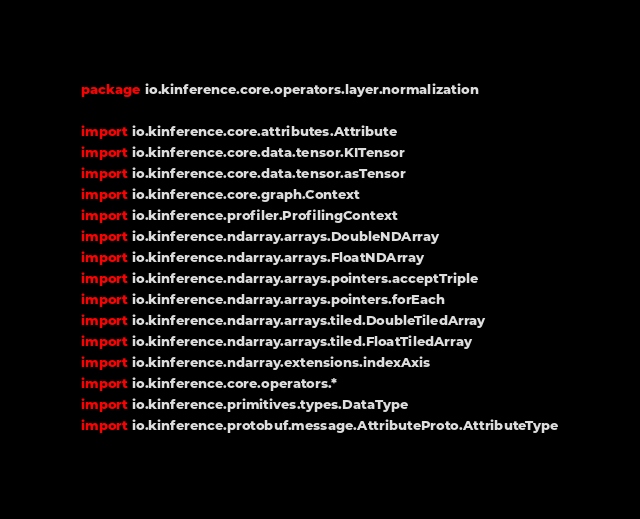<code> <loc_0><loc_0><loc_500><loc_500><_Kotlin_>package io.kinference.core.operators.layer.normalization

import io.kinference.core.attributes.Attribute
import io.kinference.core.data.tensor.KITensor
import io.kinference.core.data.tensor.asTensor
import io.kinference.core.graph.Context
import io.kinference.profiler.ProfilingContext
import io.kinference.ndarray.arrays.DoubleNDArray
import io.kinference.ndarray.arrays.FloatNDArray
import io.kinference.ndarray.arrays.pointers.acceptTriple
import io.kinference.ndarray.arrays.pointers.forEach
import io.kinference.ndarray.arrays.tiled.DoubleTiledArray
import io.kinference.ndarray.arrays.tiled.FloatTiledArray
import io.kinference.ndarray.extensions.indexAxis
import io.kinference.core.operators.*
import io.kinference.primitives.types.DataType
import io.kinference.protobuf.message.AttributeProto.AttributeType</code> 